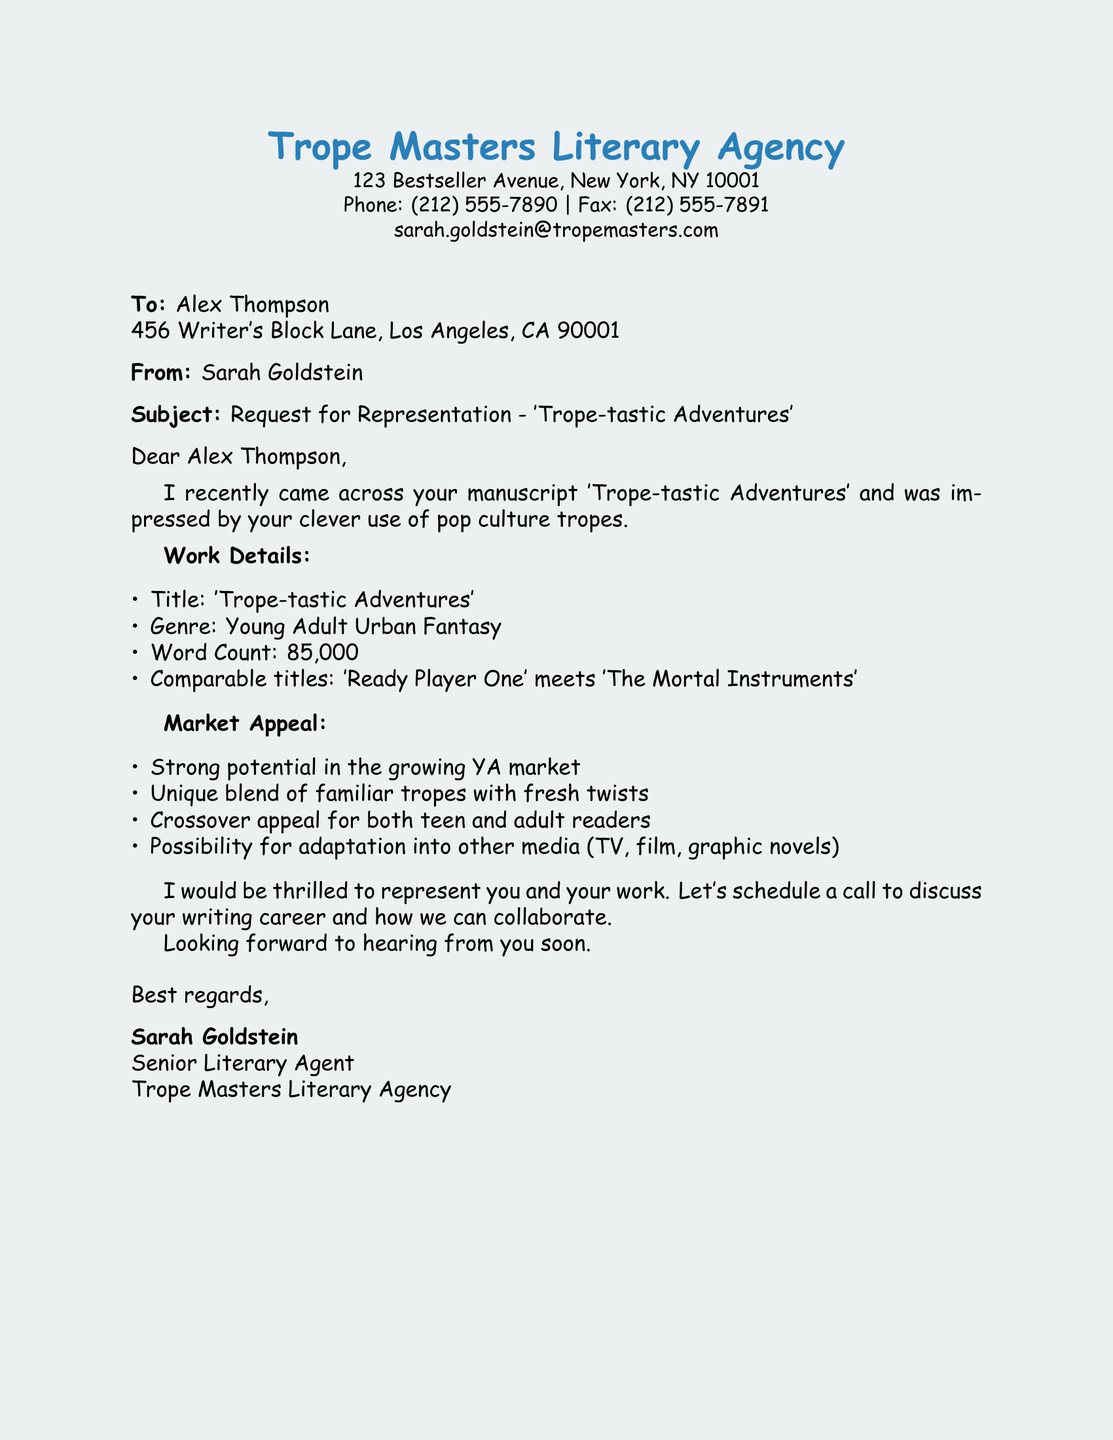What is the name of the literary agent? The name of the literary agent is included in the document header.
Answer: Sarah Goldstein What is the title of the manuscript? The title is stated clearly in the subject line and body of the document.
Answer: Trope-tastic Adventures What is the genre of the manuscript? The genre is specified in the work details section.
Answer: Young Adult Urban Fantasy What is the word count of the manuscript? The word count is listed in the work details section.
Answer: 85,000 What comparable titles are mentioned? The comparable titles are provided to offer context on the manuscript’s market positioning.
Answer: Ready Player One meets The Mortal Instruments What potential does the manuscript have for adaptation? The document discusses the manuscript's adaptability in its market appeal section.
Answer: Possibility for adaptation into other media What is the market appeal of the manuscript? The market appeal is outlined with specific selling points in the document.
Answer: Strong potential in the growing YA market How does the agent suggest scheduling further communication? The agent expresses a desire to discuss representation and suggests a method to do so.
Answer: Schedule a call What type of agency is Trope Masters? The agency type can be inferred from the title and the work it offers to do.
Answer: Literary Agency 